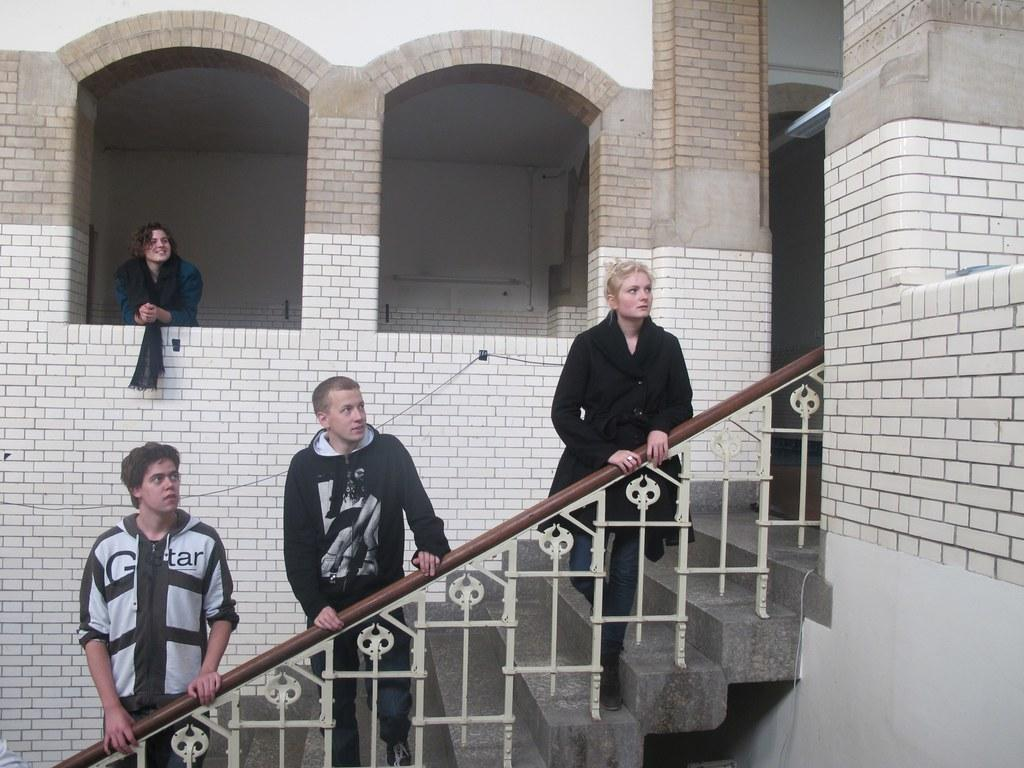What type of architectural feature is present in the image? There are steps with a railing in the image. How many people are standing on the steps? Three people are standing on the steps. What is the main feature of the building in the image? The building has a brick wall and arches. Where is the lady standing in relation to the building? The lady is standing near an arch. What is the price of the appliance being used by the lady in the image? There is no appliance present in the image, and therefore no price can be determined. 